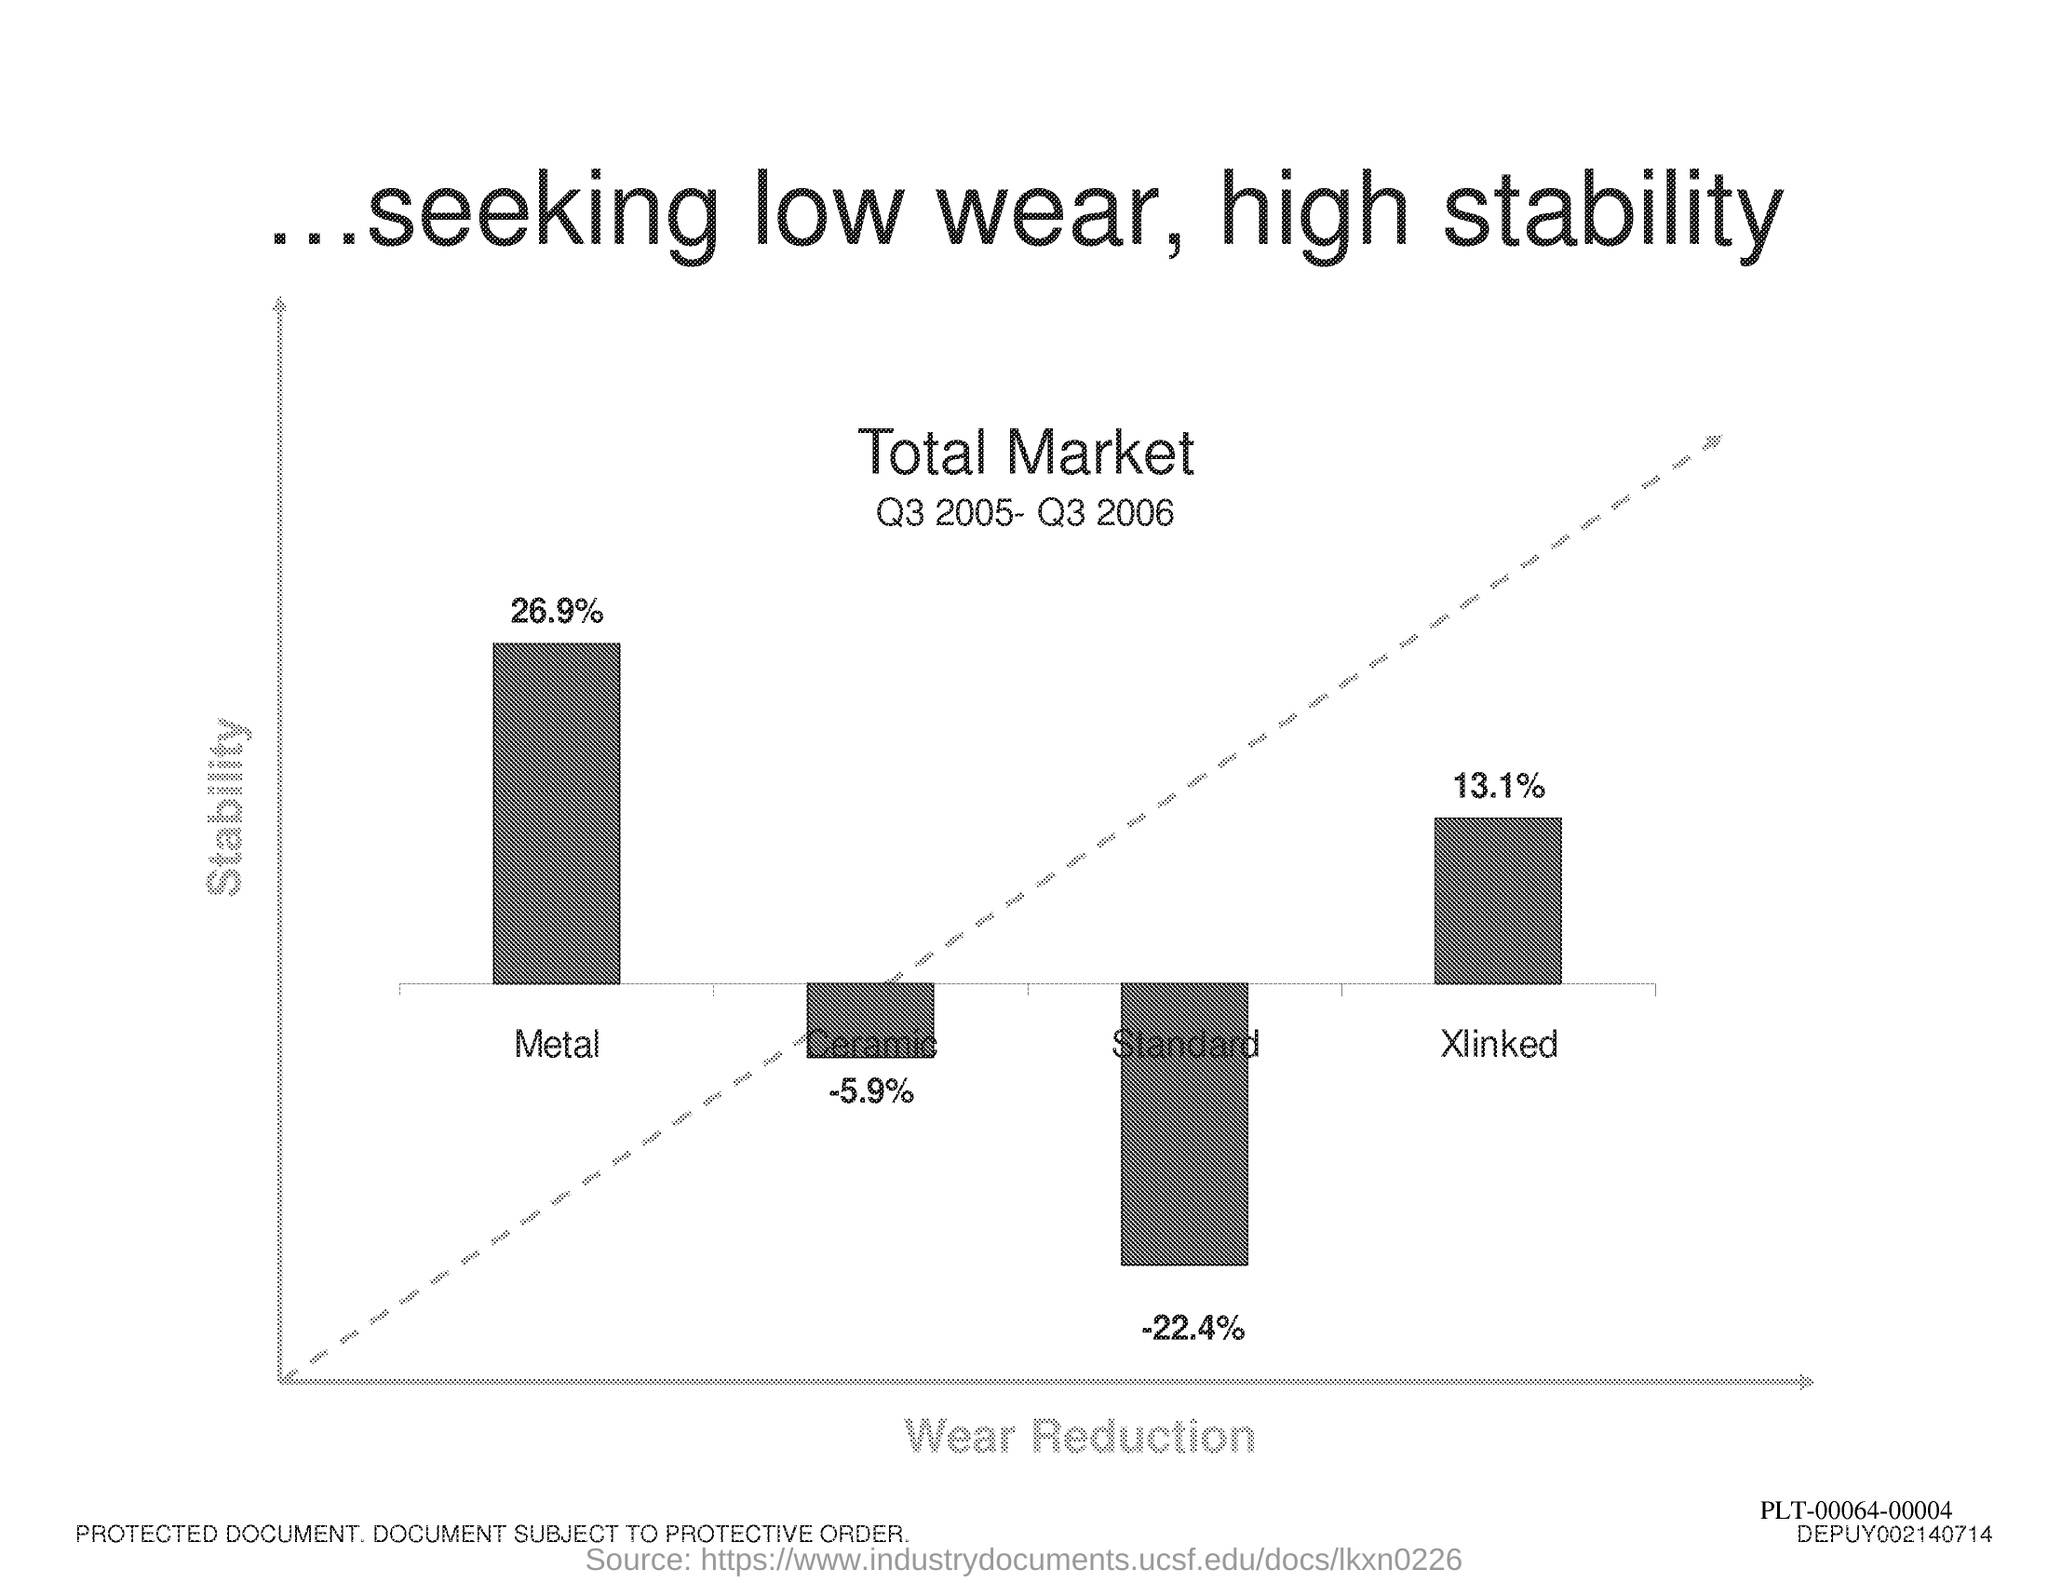Highlight a few significant elements in this photo. The x-axis displays the wear reduction values for each sample, providing a clear and informative visual representation of the results. The stability of a system is plotted on the y-axis in the graph. 